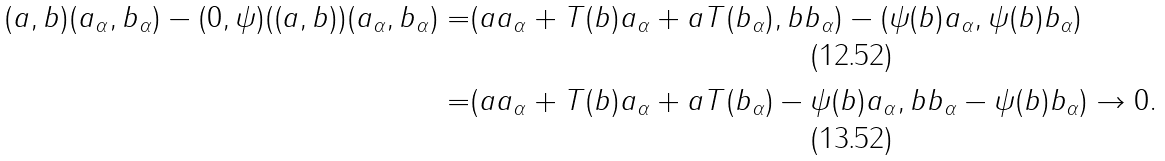Convert formula to latex. <formula><loc_0><loc_0><loc_500><loc_500>\| ( a , b ) ( a _ { \alpha } , b _ { \alpha } ) - ( 0 , \psi ) ( ( a , b ) ) ( a _ { \alpha } , b _ { \alpha } ) \| = & \| ( a a _ { \alpha } + T ( b ) a _ { \alpha } + a T ( b _ { \alpha } ) , b b _ { \alpha } ) - ( \psi ( b ) a _ { \alpha } , \psi ( b ) b _ { \alpha } ) \| \\ = & \| ( a a _ { \alpha } + T ( b ) a _ { \alpha } + a T ( b _ { \alpha } ) - \psi ( b ) a _ { \alpha } , b b _ { \alpha } - \psi ( b ) b _ { \alpha } ) \| \rightarrow 0 .</formula> 